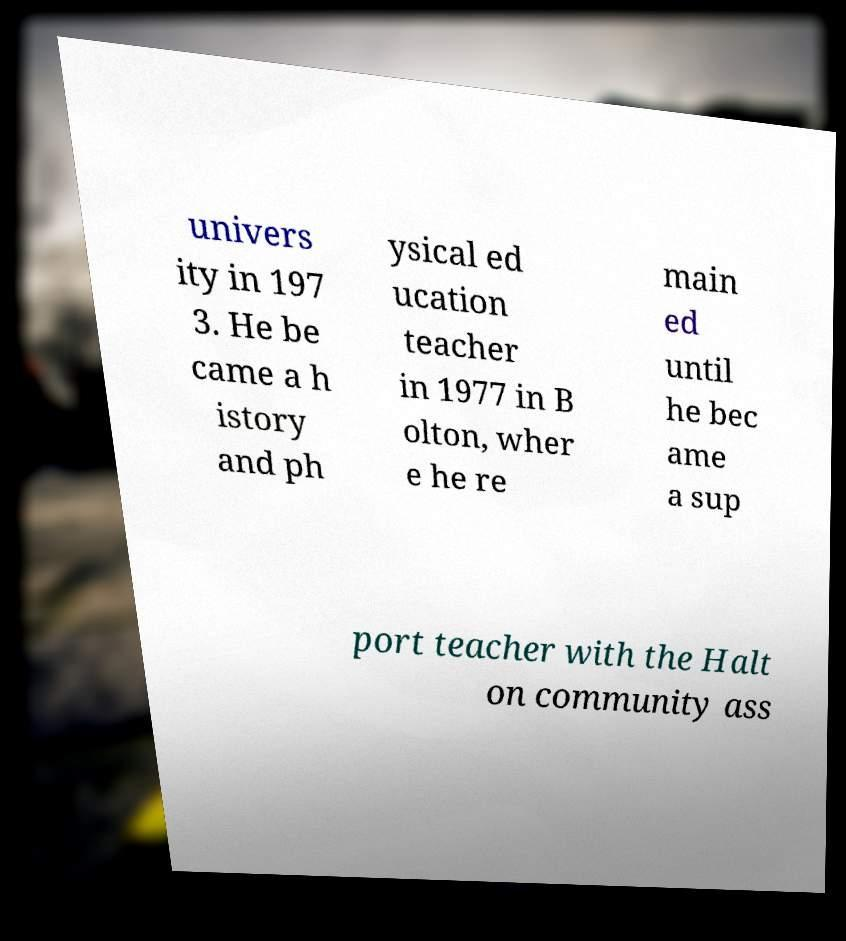For documentation purposes, I need the text within this image transcribed. Could you provide that? univers ity in 197 3. He be came a h istory and ph ysical ed ucation teacher in 1977 in B olton, wher e he re main ed until he bec ame a sup port teacher with the Halt on community ass 